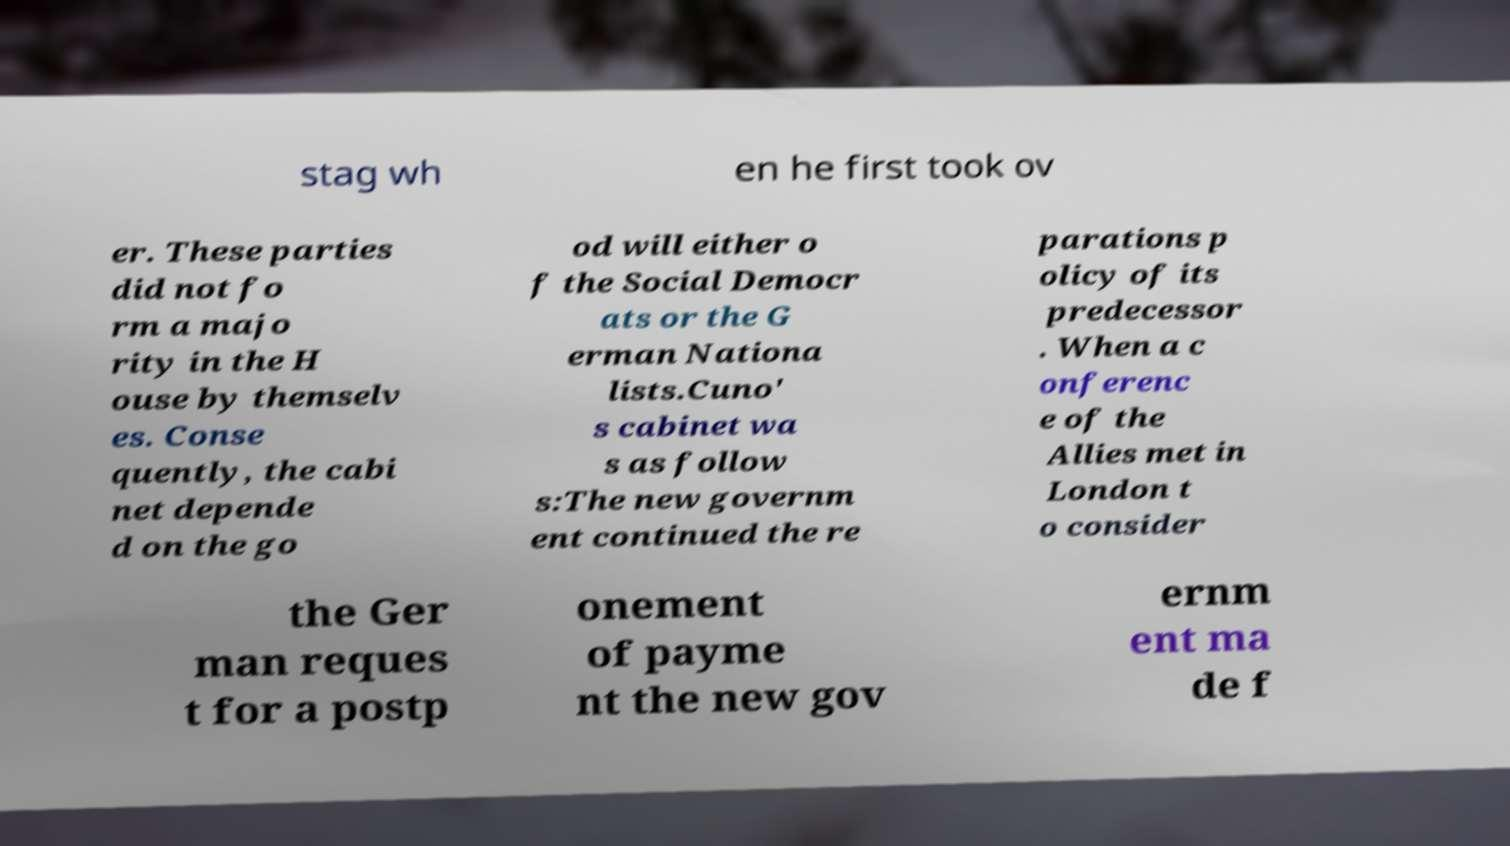I need the written content from this picture converted into text. Can you do that? stag wh en he first took ov er. These parties did not fo rm a majo rity in the H ouse by themselv es. Conse quently, the cabi net depende d on the go od will either o f the Social Democr ats or the G erman Nationa lists.Cuno' s cabinet wa s as follow s:The new governm ent continued the re parations p olicy of its predecessor . When a c onferenc e of the Allies met in London t o consider the Ger man reques t for a postp onement of payme nt the new gov ernm ent ma de f 